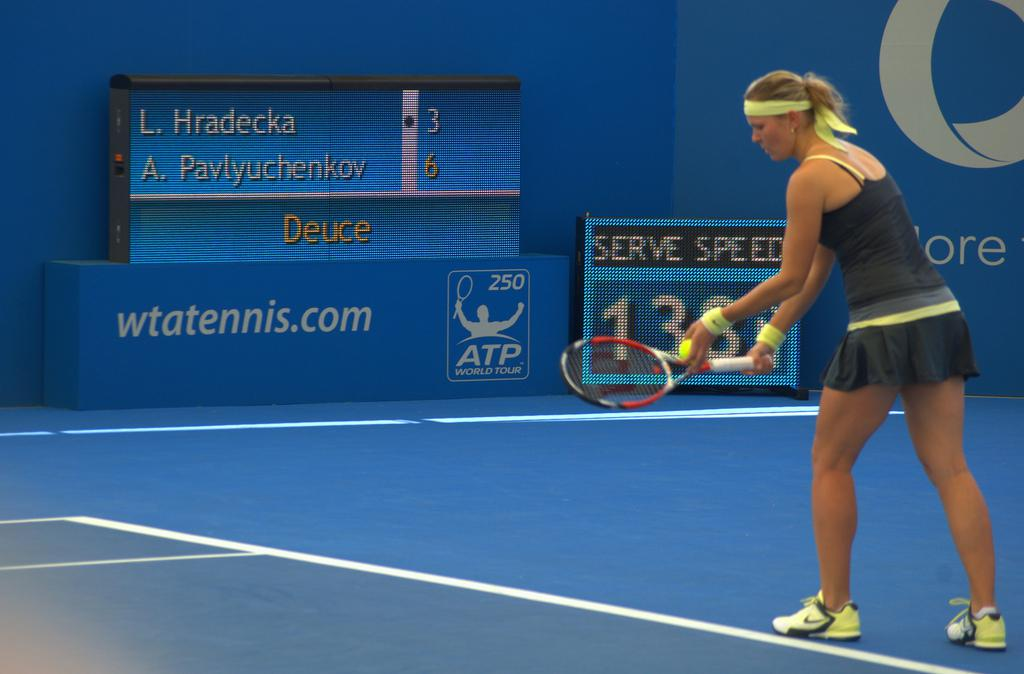Question: how is the player standing?
Choices:
A. With his back to the camera.
B. At attention for the national anthem.
C. Bending over in pain.
D. Sideways to the camera.
Answer with the letter. Answer: D Question: what was she hitting the ball with?
Choices:
A. A baseballl bat.
B. Tennis racquet.
C. The palm of her hand.
D. Her foot.
Answer with the letter. Answer: B Question: who is winning?
Choices:
A. America.
B. Russia.
C. Spain.
D. A pavlyuchenkov.
Answer with the letter. Answer: D Question: where was this picture taken?
Choices:
A. In a field.
B. At a baseball game.
C. At a tennis match.
D. At a football game.
Answer with the letter. Answer: C Question: what shape is the ball?
Choices:
A. Oblong.
B. Oval.
C. Round.
D. Spherical.
Answer with the letter. Answer: C Question: what hand is it in?
Choices:
A. Her right hand.
B. Her left hand.
C. The upper hand.
D. The lower hand.
Answer with the letter. Answer: A Question: where is she at?
Choices:
A. The park.
B. The volleyball court.
C. The tennis court.
D. Overlooking the river.
Answer with the letter. Answer: C Question: what type of court is it?
Choices:
A. A badminton court.
B. A tennis court.
C. A volleyball court.
D. A racquetball court.
Answer with the letter. Answer: B Question: what color is the word deuce?
Choices:
A. Yellow.
B. Black.
C. Red.
D. Blue.
Answer with the letter. Answer: A Question: where is there a board measuring serve speed?
Choices:
A. Over the table.
B. By the sitting man.
C. By the counter.
D. In the corner.
Answer with the letter. Answer: D Question: what is the score?
Choices:
A. 7-5.
B. 5-1.
C. The score is 3-6.
D. 6-0.
Answer with the letter. Answer: C Question: what is the tennis player about to do?
Choices:
A. Serve the ball.
B. Hit the ball back.
C. Run towards the net.
D. Stretch.
Answer with the letter. Answer: A Question: who has hair pulled up?
Choices:
A. Men.
B. Kids.
C. Cooks.
D. Girl.
Answer with the letter. Answer: D Question: who is wearing wrist supports?
Choices:
A. The boy.
B. The player.
C. The dad.
D. Girl.
Answer with the letter. Answer: D Question: why was she holding the ball?
Choices:
A. She is passing to the other player.
B. It's her serve.
C. She's the pitcher.
D. She is about to hit the ball.
Answer with the letter. Answer: D Question: who was hitting the bal?
Choices:
A. A man.
B. A child.
C. A tennis player.
D. A lady.
Answer with the letter. Answer: D Question: who is looking at tennis ball?
Choices:
A. Girl.
B. The player.
C. The boy.
D. The dog.
Answer with the letter. Answer: A Question: what information does the sign in the corner give?
Choices:
A. Serve speed.
B. Where the restroom is.
C. Children are playing.
D. Construction.
Answer with the letter. Answer: A Question: what is the player wearing?
Choices:
A. A jersey.
B. A black tennis outfit.
C. A tshirt.
D. A tank top.
Answer with the letter. Answer: B 